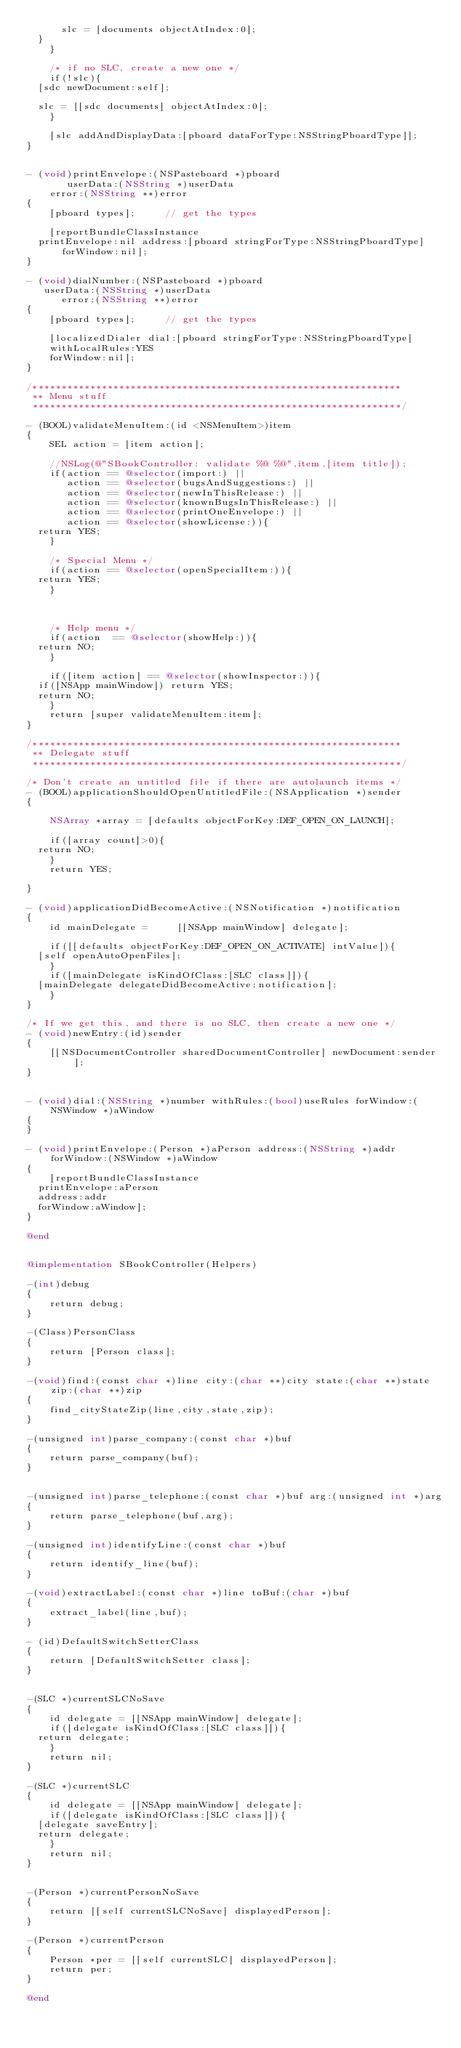<code> <loc_0><loc_0><loc_500><loc_500><_ObjectiveC_>	    slc = [documents objectAtIndex:0];
	}
    }

    /* if no SLC, create a new one */
    if(!slc){
	[sdc newDocument:self];
    
	slc = [[sdc documents] objectAtIndex:0];
    }

    [slc addAndDisplayData:[pboard dataForType:NSStringPboardType]];
}


- (void)printEnvelope:(NSPasteboard *)pboard
	     userData:(NSString *)userData
		error:(NSString **)error
{
    [pboard types];			// get the types

    [reportBundleClassInstance
	printEnvelope:nil address:[pboard stringForType:NSStringPboardType] forWindow:nil];
}

- (void)dialNumber:(NSPasteboard *)pboard
	 userData:(NSString *)userData
	    error:(NSString **)error
{
    [pboard types];			// get the types

    [localizedDialer dial:[pboard stringForType:NSStringPboardType]
	  withLocalRules:YES
	  forWindow:nil];
}

/****************************************************************
 ** Menu stuff
 ****************************************************************/

- (BOOL)validateMenuItem:(id <NSMenuItem>)item
{
    SEL action = [item action];

    //NSLog(@"SBookController: validate %@ %@",item,[item title]);
    if(action == @selector(import:) ||
       action == @selector(bugsAndSuggestions:) || 
       action == @selector(newInThisRelease:) ||
       action == @selector(knownBugsInThisRelease:) ||
       action == @selector(printOneEnvelope:) ||
       action == @selector(showLicense:)){
	return YES;
    }

    /* Special Menu */
    if(action == @selector(openSpecialItem:)){
	return YES;
    }

    

    /* Help menu */
    if(action  == @selector(showHelp:)){
	return NO;
    }

    if([item action] == @selector(showInspector:)){
	if([NSApp mainWindow]) return YES;
	return NO;
    }
    return [super validateMenuItem:item];
}

/****************************************************************
 ** Delegate stuff
 ****************************************************************/

/* Don't create an untitled file if there are autolaunch items */
- (BOOL)applicationShouldOpenUntitledFile:(NSApplication *)sender
{
    
    NSArray *array = [defaults objectForKey:DEF_OPEN_ON_LAUNCH];

    if([array count]>0){
	return NO;
    }
    return YES;

}

- (void)applicationDidBecomeActive:(NSNotification *)notification
{
    id mainDelegate =     [[NSApp mainWindow] delegate];

    if([[defaults objectForKey:DEF_OPEN_ON_ACTIVATE] intValue]){
	[self openAutoOpenFiles];
    }
    if([mainDelegate isKindOfClass:[SLC class]]){
	[mainDelegate delegateDidBecomeActive:notification];
    }
}

/* If we get this, and there is no SLC, then create a new one */
- (void)newEntry:(id)sender
{
    [[NSDocumentController sharedDocumentController] newDocument:sender];
}


- (void)dial:(NSString *)number withRules:(bool)useRules forWindow:(NSWindow *)aWindow
{
}

- (void)printEnvelope:(Person *)aPerson address:(NSString *)addr forWindow:(NSWindow *)aWindow
{
    [reportBundleClassInstance
	printEnvelope:aPerson
	address:addr
	forWindow:aWindow];
}

@end


@implementation SBookController(Helpers)

-(int)debug
{
    return debug;
}

-(Class)PersonClass
{
    return [Person class];
}

-(void)find:(const char *)line city:(char **)city state:(char **)state zip:(char **)zip
{
    find_cityStateZip(line,city,state,zip);
}

-(unsigned int)parse_company:(const char *)buf
{
    return parse_company(buf);
}


-(unsigned int)parse_telephone:(const char *)buf arg:(unsigned int *)arg
{
    return parse_telephone(buf,arg);
}

-(unsigned int)identifyLine:(const char *)buf
{
    return identify_line(buf);
}

-(void)extractLabel:(const char *)line toBuf:(char *)buf
{
    extract_label(line,buf);
}

- (id)DefaultSwitchSetterClass
{
    return [DefaultSwitchSetter class];
}


-(SLC *)currentSLCNoSave
{
    id delegate = [[NSApp mainWindow] delegate];
    if([delegate isKindOfClass:[SLC class]]){
	return delegate;
    }
    return nil;
}

-(SLC *)currentSLC
{
    id delegate = [[NSApp mainWindow] delegate];
    if([delegate isKindOfClass:[SLC class]]){
	[delegate saveEntry];
	return delegate;
    }
    return nil;
}


-(Person *)currentPersonNoSave
{
    return [[self currentSLCNoSave] displayedPerson];
}

-(Person *)currentPerson	
{
    Person *per = [[self currentSLC] displayedPerson];
    return per;
}

@end
  
</code> 